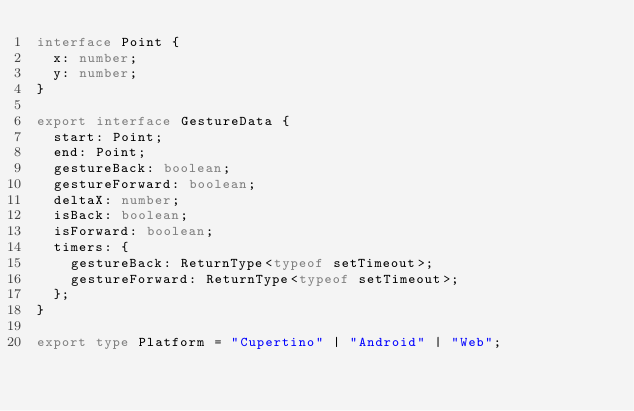<code> <loc_0><loc_0><loc_500><loc_500><_TypeScript_>interface Point {
  x: number;
  y: number;
}

export interface GestureData {
  start: Point;
  end: Point;
  gestureBack: boolean;
  gestureForward: boolean;
  deltaX: number;
  isBack: boolean;
  isForward: boolean;
  timers: {
    gestureBack: ReturnType<typeof setTimeout>;
    gestureForward: ReturnType<typeof setTimeout>;
  };
}

export type Platform = "Cupertino" | "Android" | "Web";
</code> 